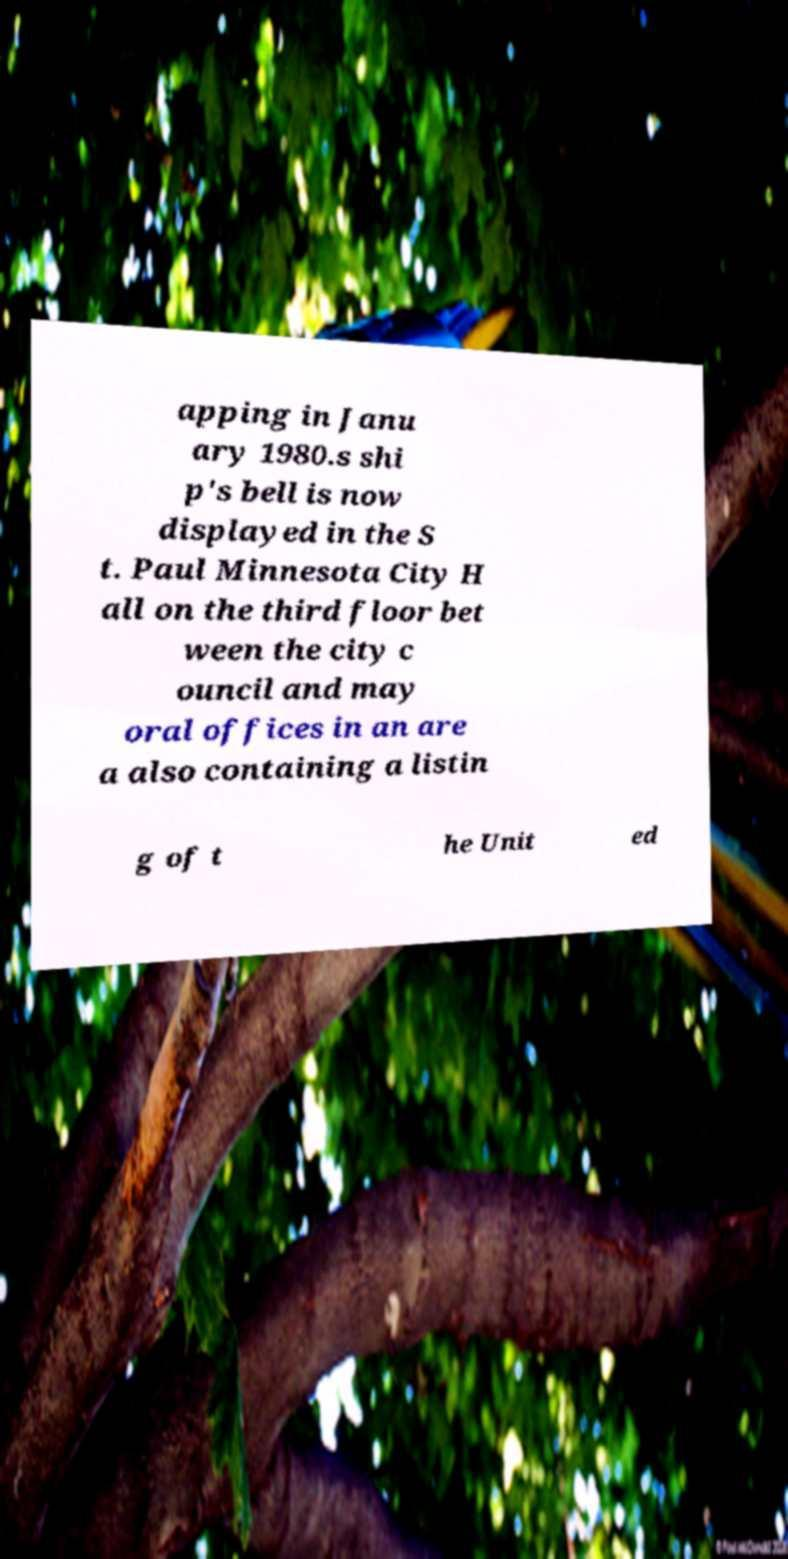Could you extract and type out the text from this image? apping in Janu ary 1980.s shi p's bell is now displayed in the S t. Paul Minnesota City H all on the third floor bet ween the city c ouncil and may oral offices in an are a also containing a listin g of t he Unit ed 